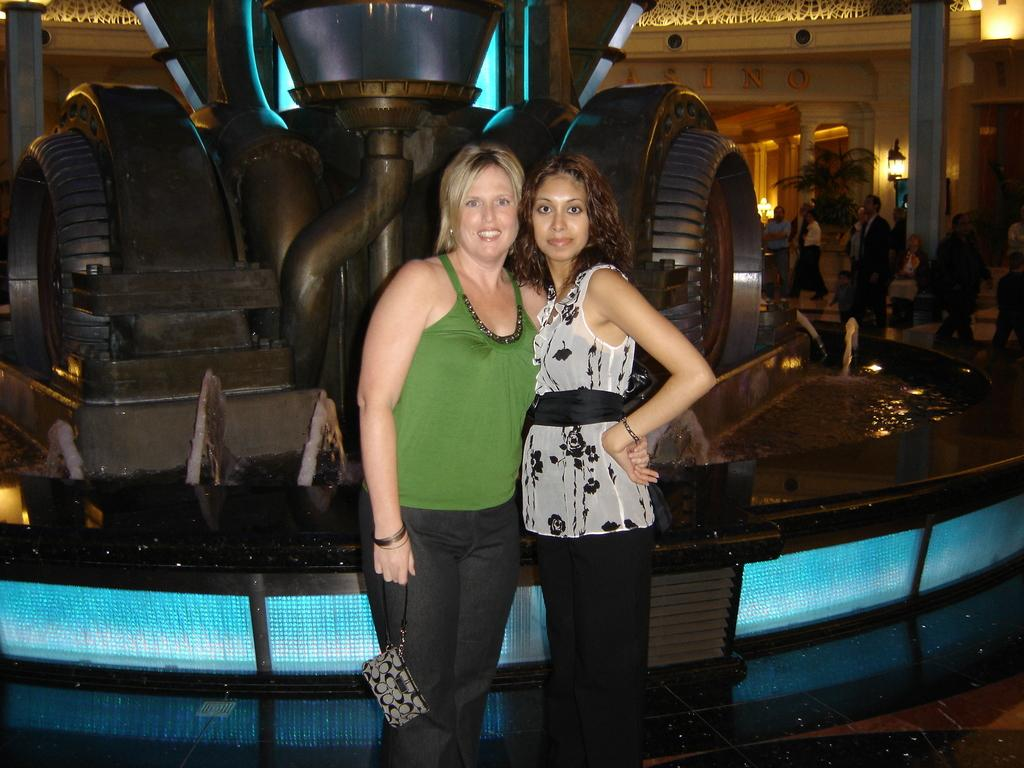How many women are present in the image? There are 2 women standing in the image. What is visible in the background of the image? There are people, lamps, and a plant in the background of the image. What is located behind the women in the image? There is a sculpture behind the women. Can you describe the environment in the image? The environment includes water, and there are people and objects in the background. How many kittens are participating in the event in the image? There are no kittens or events present in the image. What is the effect of the shake on the sculpture in the image? There is no shaking or movement of the sculpture in the image; it is stationary. 